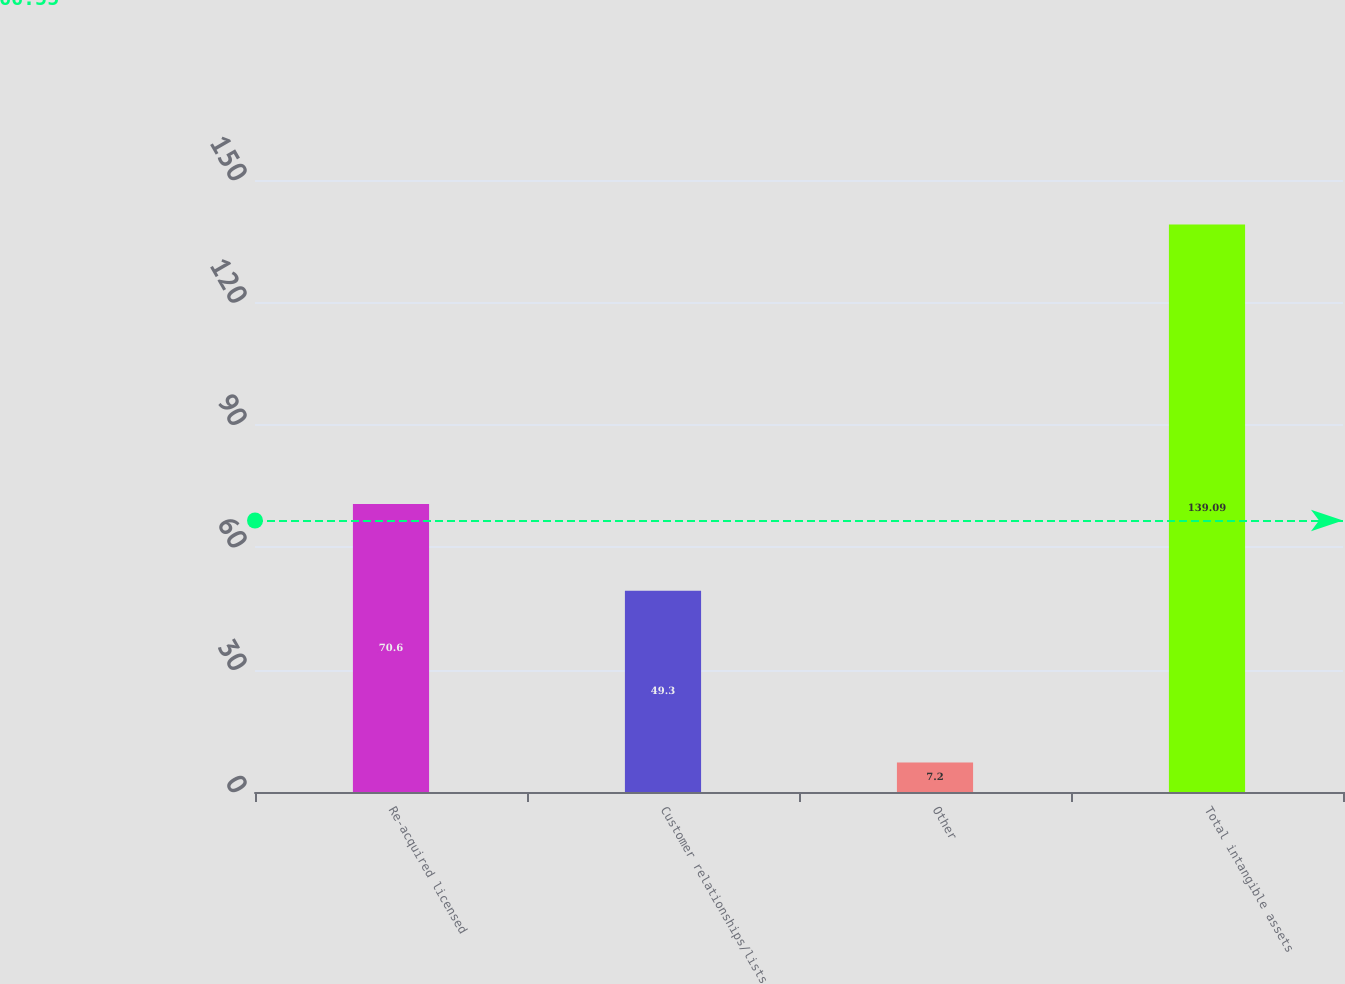Convert chart to OTSL. <chart><loc_0><loc_0><loc_500><loc_500><bar_chart><fcel>Re-acquired licensed<fcel>Customer relationships/lists<fcel>Other<fcel>Total intangible assets<nl><fcel>70.6<fcel>49.3<fcel>7.2<fcel>139.09<nl></chart> 